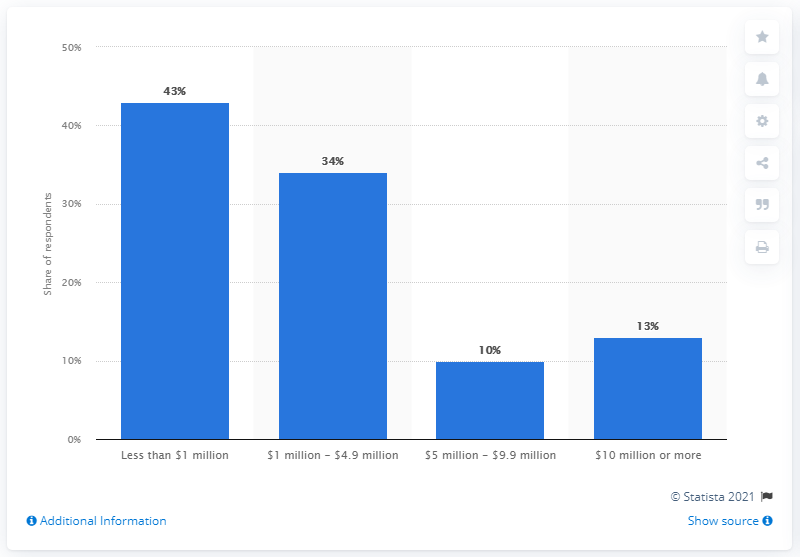Outline some significant characteristics in this image. According to the responses, 34% of respondents reported that their largest meeting had a positive economic impact of between $1 million and $4.9 million on the host destination's economy. 